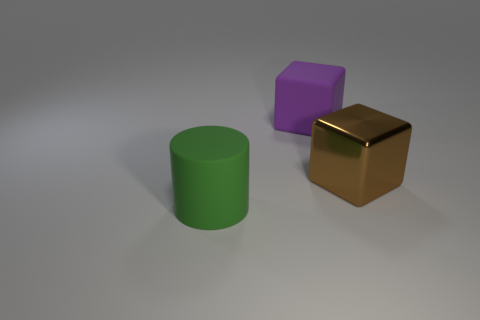What is the material of the big cube that is to the left of the thing to the right of the large purple matte object?
Keep it short and to the point. Rubber. There is another large object that is the same shape as the large brown object; what is its material?
Give a very brief answer. Rubber. Does the rubber object behind the green matte object have the same size as the green rubber object?
Offer a terse response. Yes. What number of matte things are either big brown cylinders or large cubes?
Offer a very short reply. 1. What is the material of the big object that is both on the left side of the large brown cube and in front of the big purple rubber block?
Keep it short and to the point. Rubber. Do the big brown object and the large purple cube have the same material?
Provide a short and direct response. No. What size is the thing that is both in front of the big purple block and to the left of the brown shiny cube?
Provide a succinct answer. Large. The big green matte object is what shape?
Make the answer very short. Cylinder. How many objects are either cubes or big things behind the large cylinder?
Provide a succinct answer. 2. Is the color of the rubber cylinder that is on the left side of the large shiny block the same as the big metal thing?
Provide a short and direct response. No. 